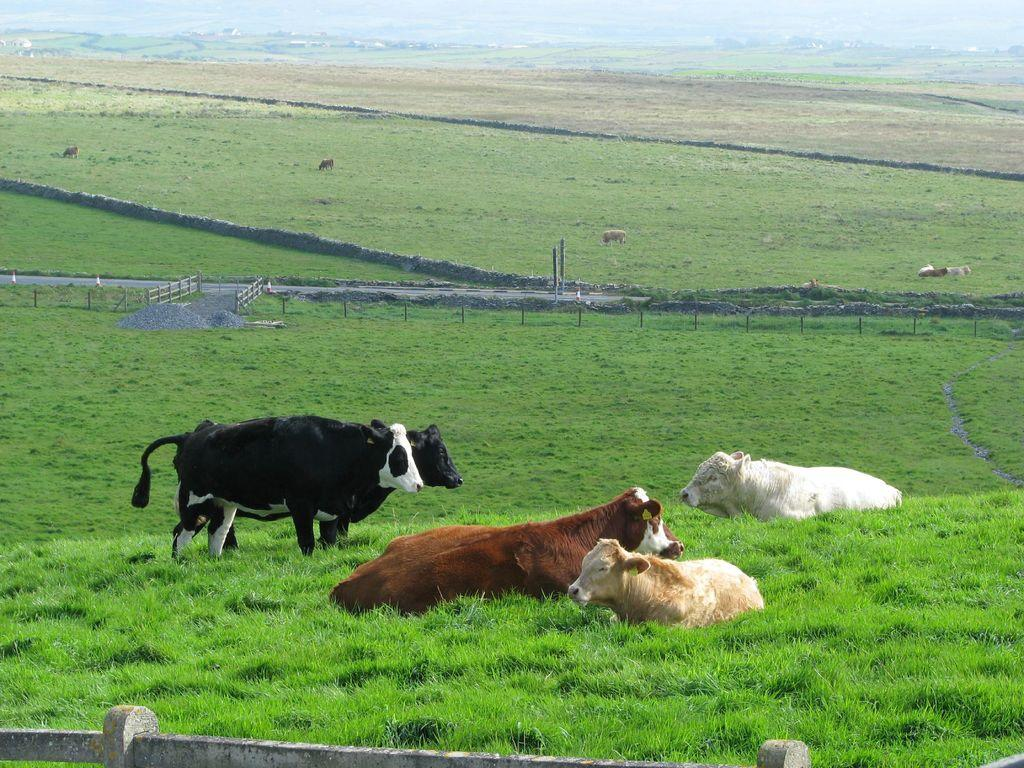What type of animals can be seen on the surface in the image? There are animals on the surface in the image, but their specific type is not mentioned in the facts. What kind of barrier is present in the image? There is a metal grill fence in the image. What type of landscape can be seen in the image? There are farm fields visible in the image. What color is the grass in the image? There is green grass in the image. What type of alarm can be heard going off in the image? There is no mention of an alarm or any sound in the image, so it cannot be heard. Can you describe the wings of the animals in the image? The facts do not specify the type of animals in the image, so we cannot describe their wings. 